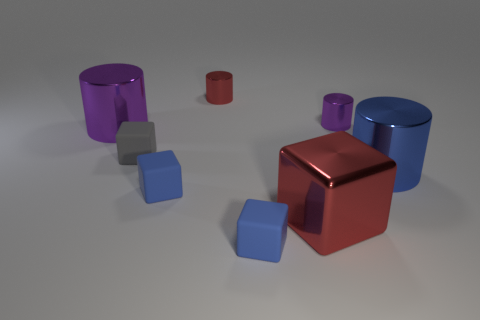The red thing in front of the large cylinder that is behind the matte thing that is behind the blue metallic object is made of what material?
Offer a terse response. Metal. Are there any big shiny things right of the big purple shiny cylinder?
Your response must be concise. Yes. The red metallic thing that is the same size as the gray cube is what shape?
Ensure brevity in your answer.  Cylinder. Does the large red cube have the same material as the small gray object?
Offer a very short reply. No. What number of rubber objects are large green spheres or tiny cylinders?
Provide a succinct answer. 0. There is a shiny thing that is the same color as the large shiny cube; what is its shape?
Your answer should be very brief. Cylinder. There is a cube behind the big blue metallic cylinder; does it have the same color as the big block?
Offer a very short reply. No. There is a red shiny object that is behind the purple metallic cylinder to the left of the big block; what is its shape?
Make the answer very short. Cylinder. What number of objects are big objects that are right of the red metal cube or small blue rubber blocks left of the tiny red cylinder?
Provide a short and direct response. 2. What is the shape of the red object that is made of the same material as the small red cylinder?
Offer a terse response. Cube. 